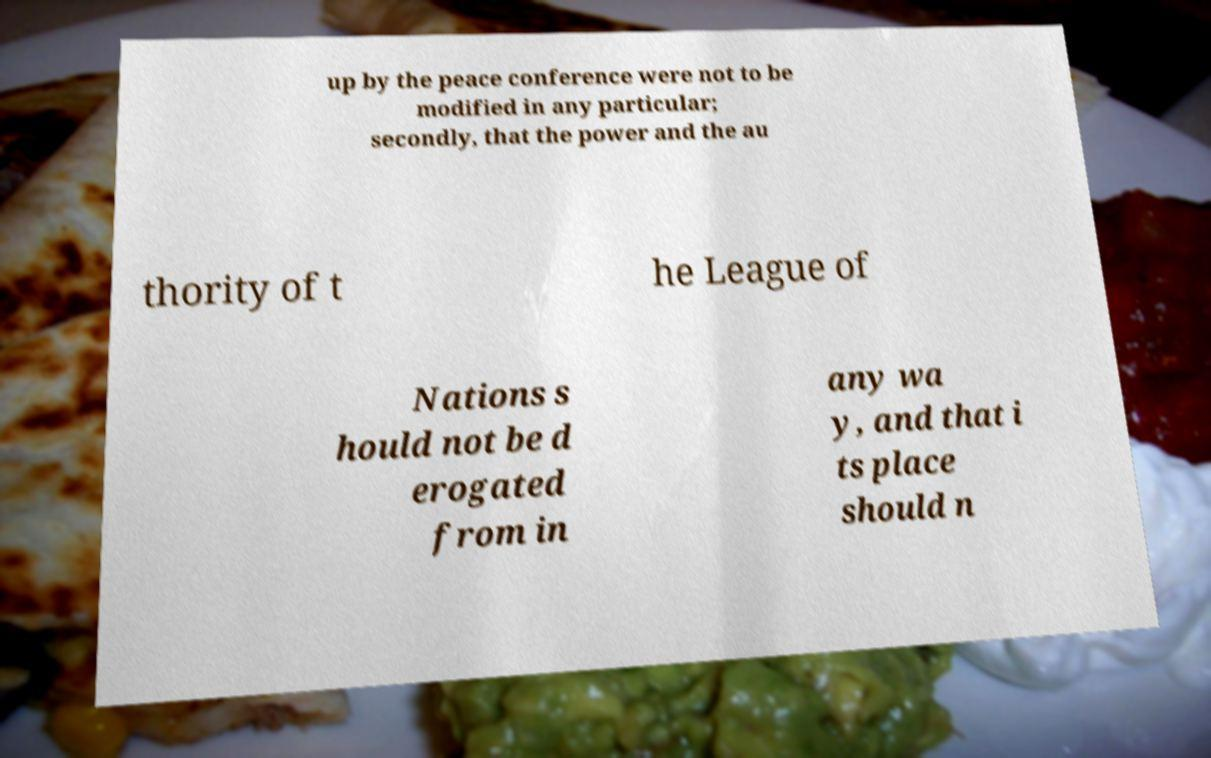I need the written content from this picture converted into text. Can you do that? up by the peace conference were not to be modified in any particular; secondly, that the power and the au thority of t he League of Nations s hould not be d erogated from in any wa y, and that i ts place should n 